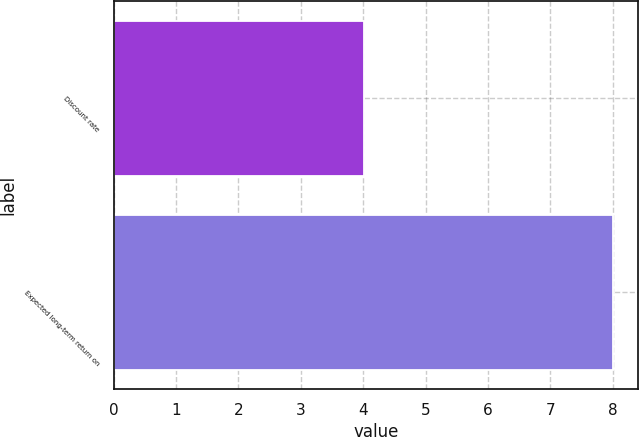Convert chart to OTSL. <chart><loc_0><loc_0><loc_500><loc_500><bar_chart><fcel>Discount rate<fcel>Expected long-term return on<nl><fcel>4.01<fcel>8<nl></chart> 